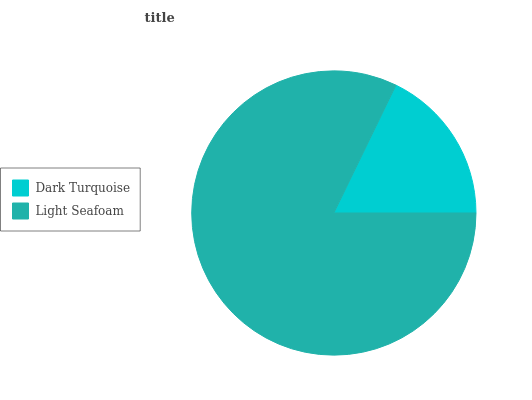Is Dark Turquoise the minimum?
Answer yes or no. Yes. Is Light Seafoam the maximum?
Answer yes or no. Yes. Is Light Seafoam the minimum?
Answer yes or no. No. Is Light Seafoam greater than Dark Turquoise?
Answer yes or no. Yes. Is Dark Turquoise less than Light Seafoam?
Answer yes or no. Yes. Is Dark Turquoise greater than Light Seafoam?
Answer yes or no. No. Is Light Seafoam less than Dark Turquoise?
Answer yes or no. No. Is Light Seafoam the high median?
Answer yes or no. Yes. Is Dark Turquoise the low median?
Answer yes or no. Yes. Is Dark Turquoise the high median?
Answer yes or no. No. Is Light Seafoam the low median?
Answer yes or no. No. 